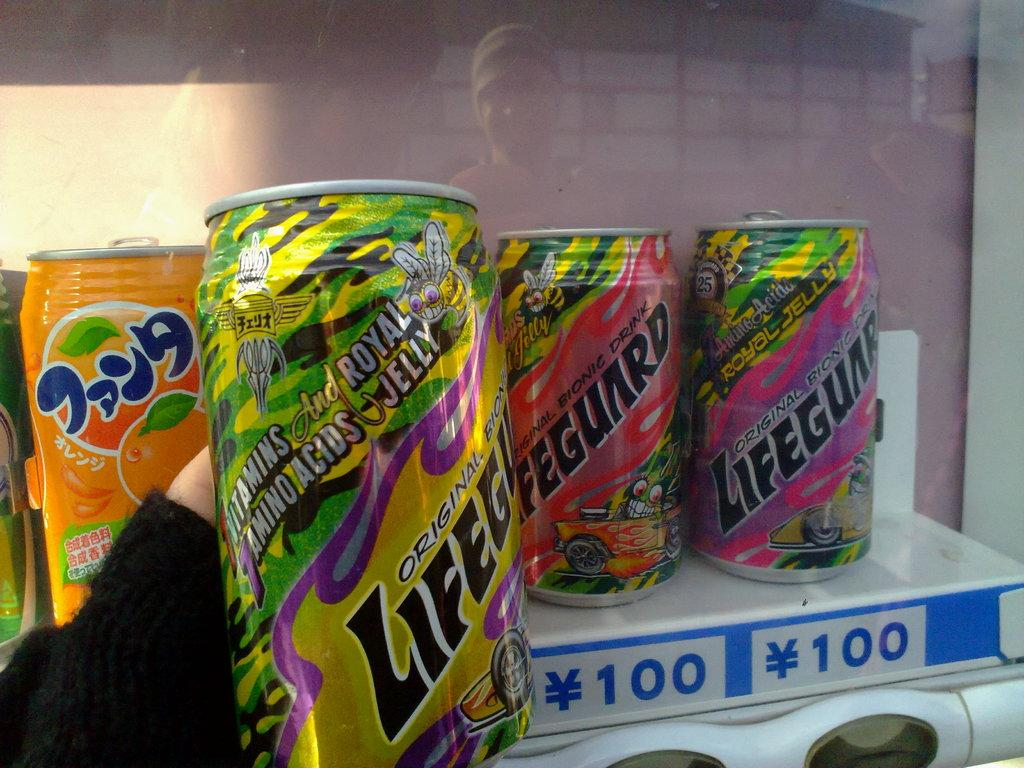<image>
Present a compact description of the photo's key features. several colorful cans of Lifeguard drink in a vending machine 